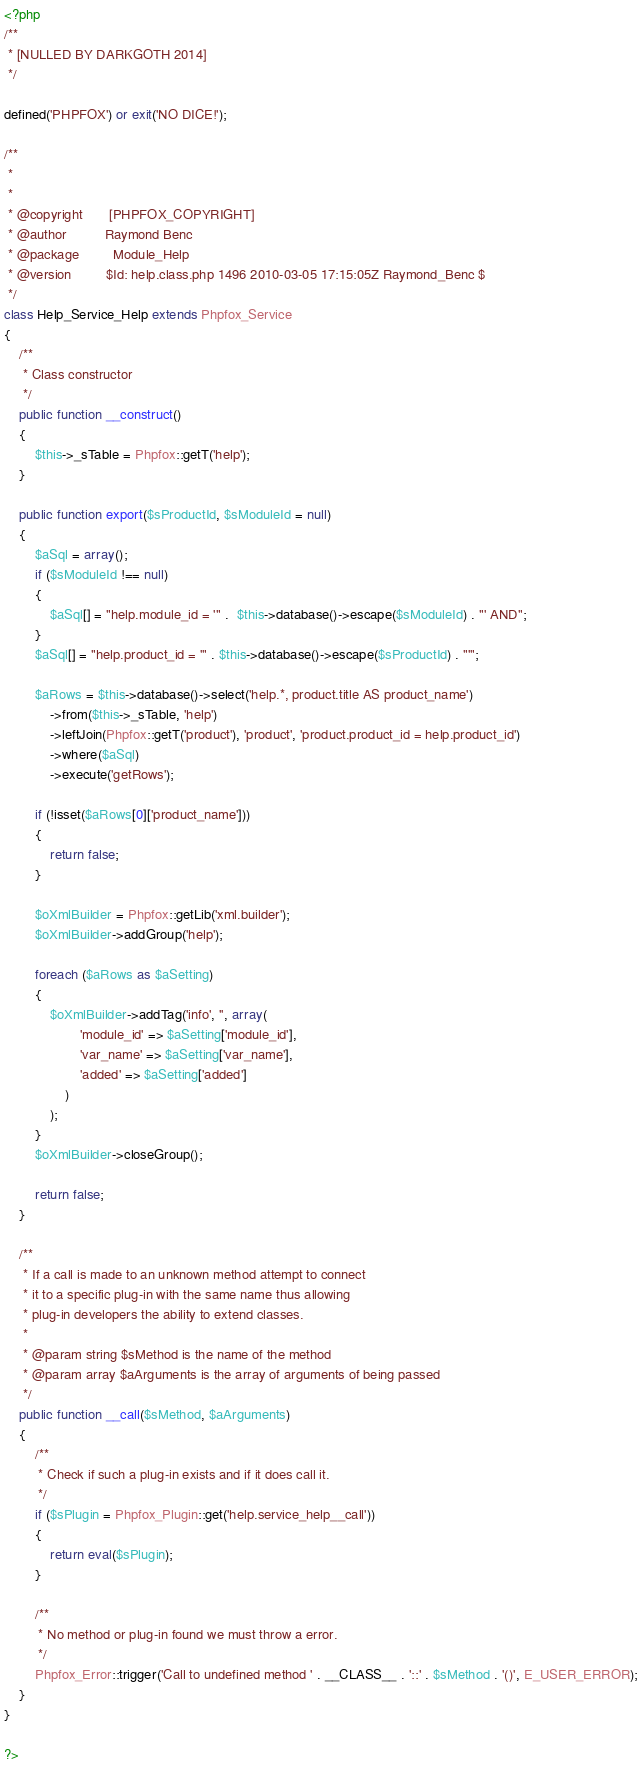Convert code to text. <code><loc_0><loc_0><loc_500><loc_500><_PHP_><?php
/**
 * [NULLED BY DARKGOTH 2014]
 */

defined('PHPFOX') or exit('NO DICE!');

/**
 * 
 * 
 * @copyright		[PHPFOX_COPYRIGHT]
 * @author  		Raymond Benc
 * @package  		Module_Help
 * @version 		$Id: help.class.php 1496 2010-03-05 17:15:05Z Raymond_Benc $
 */
class Help_Service_Help extends Phpfox_Service 
{
	/**
	 * Class constructor
	 */	
	public function __construct()
	{	
		$this->_sTable = Phpfox::getT('help');
	}
	
	public function export($sProductId, $sModuleId = null)
	{
		$aSql = array();
		if ($sModuleId !== null)
		{
			$aSql[] = "help.module_id = '" .  $this->database()->escape($sModuleId) . "' AND";
		}
		$aSql[] = "help.product_id = '" . $this->database()->escape($sProductId) . "'";
		
		$aRows = $this->database()->select('help.*, product.title AS product_name')
			->from($this->_sTable, 'help')
			->leftJoin(Phpfox::getT('product'), 'product', 'product.product_id = help.product_id')
			->where($aSql)
			->execute('getRows');
		
		if (!isset($aRows[0]['product_name']))
		{
			return false;
		}		
		
		$oXmlBuilder = Phpfox::getLib('xml.builder');
		$oXmlBuilder->addGroup('help');
			
		foreach ($aRows as $aSetting)
		{
			$oXmlBuilder->addTag('info', '', array(
					'module_id' => $aSetting['module_id'],
					'var_name' => $aSetting['var_name'],
					'added' => $aSetting['added']			
				)
			);			
		}	
		$oXmlBuilder->closeGroup();
				
		return false;
	}	

	/**
	 * If a call is made to an unknown method attempt to connect
	 * it to a specific plug-in with the same name thus allowing 
	 * plug-in developers the ability to extend classes.
	 *
	 * @param string $sMethod is the name of the method
	 * @param array $aArguments is the array of arguments of being passed
	 */
	public function __call($sMethod, $aArguments)
	{
		/**
		 * Check if such a plug-in exists and if it does call it.
		 */
		if ($sPlugin = Phpfox_Plugin::get('help.service_help__call'))
		{
			return eval($sPlugin);
		}
			
		/**
		 * No method or plug-in found we must throw a error.
		 */
		Phpfox_Error::trigger('Call to undefined method ' . __CLASS__ . '::' . $sMethod . '()', E_USER_ERROR);
	}
}

?></code> 